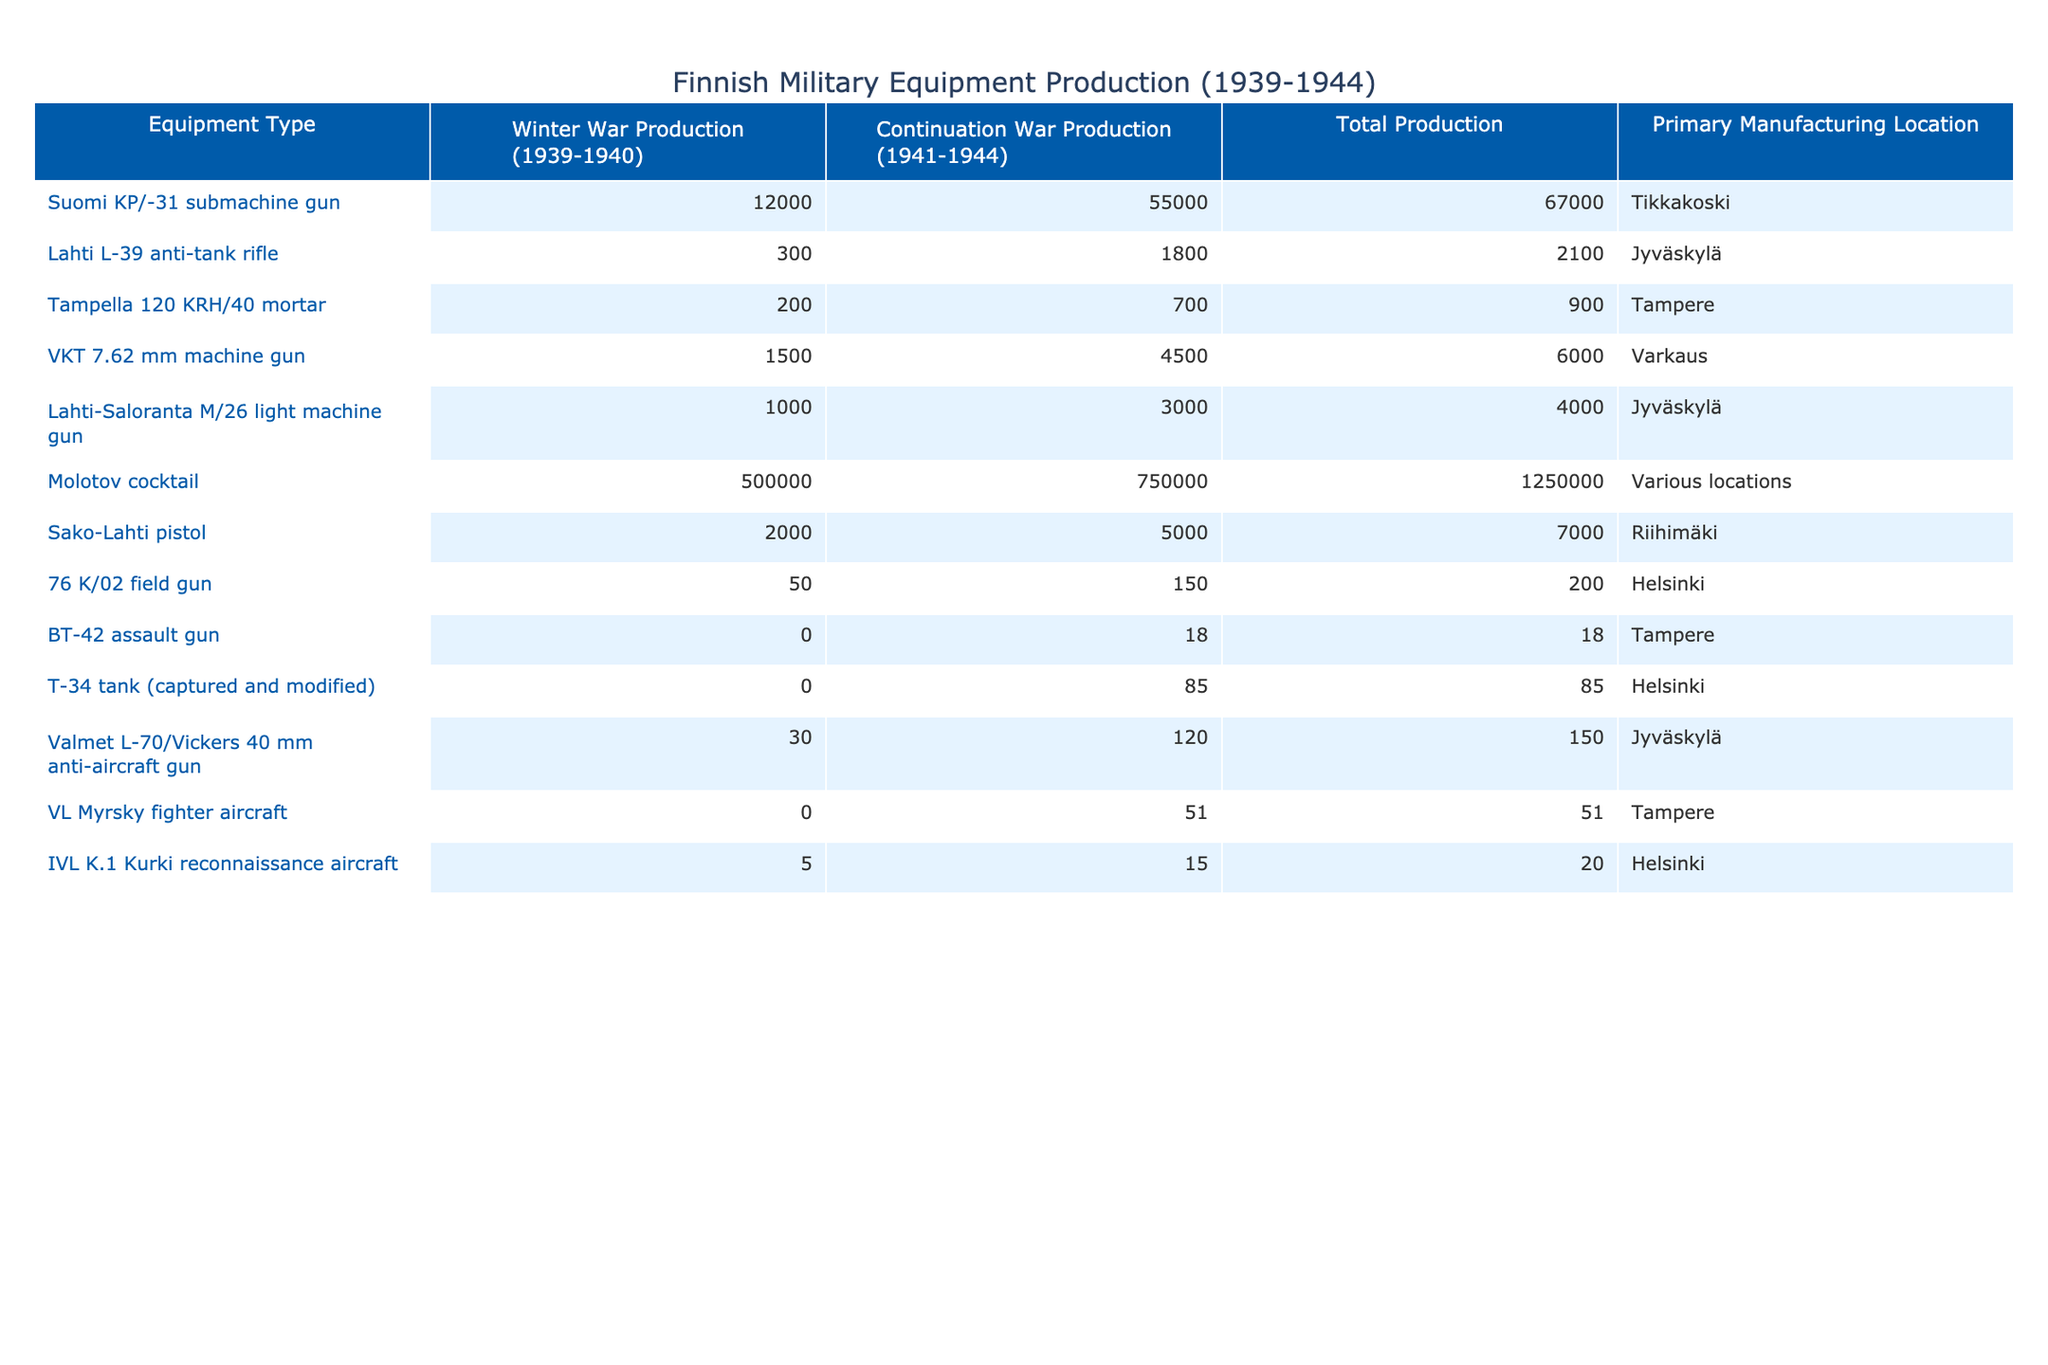What is the total production of the Molotov cocktail during the Winter War and Continuation War? The table shows that the production of the Molotov cocktail was 500,000 during the Winter War and 750,000 during the Continuation War. To find the total, we sum these two figures: 500,000 + 750,000 = 1,250,000.
Answer: 1,250,000 Which equipment was produced at the highest quantity during the Continuation War? The table lists the total production of various equipment during the Continuation War. The highest value is 55,000 for the Suomi KP/-31 submachine gun.
Answer: Suomi KP/-31 submachine gun What is the total production of anti-tank rifles over both wars? According to the table, the Lahti L-39 anti-tank rifle had a Winter War production of 300 and a Continuation War production of 1,800. We add these together: 300 + 1,800 = 2,100.
Answer: 2,100 Did any equipment have zero production during the Winter War? In the table, the BT-42 assault gun and the T-34 tank (captured and modified) both have a Winter War production value of 0. Thus, the statement is true.
Answer: Yes What is the difference in total production between the Suomi KP/-31 submachine gun and the Tampella 120 KRH/40 mortar? The total production for the Suomi KP/-31 is 67,000 and for the Tampella 120 KRH/40 mortar is 900. The difference can be calculated as follows: 67,000 - 900 = 66,100.
Answer: 66,100 Which equipment has the lowest total production, and what was the production location? The data shows that the BT-42 assault gun has the lowest total production, with only 18 units produced. The primary manufacturing location for this equipment is Tampere.
Answer: BT-42 assault gun, Tampere How many weapons were produced in total at the Jyväskylä location? The table indicates that at Jyväskylä, the following equipment was produced: Lahti L-39 anti-tank rifle (2,100), Lahti-Saloranta M/26 light machine gun (4,000), and Valmet L-70/Vickers 40 mm anti-aircraft gun (150). Adding these values gives us: 2,100 + 4,000 + 150 = 6,250.
Answer: 6,250 What fraction of the total production for the Molotov cocktail does the Winter War production represent? The total production for the Molotov cocktail is 1,250,000, with 500,000 produced during the Winter War. The fraction is calculated as 500,000 / 1,250,000 = 0.4 or 40%.
Answer: 40% Is it true that the IVL K.1 Kurki reconnaissance aircraft had more production in the Continuation War than in the Winter War? The IVL K.1 Kurki reconnaissance aircraft had a production of 5 during the Winter War and 15 during the Continuation War. Since 15 is greater than 5, the statement is true.
Answer: Yes What percentage of the total production of the Lahti-Saloranta M/26 light machine gun occurred during the Continuation War? Total production of the Lahti-Saloranta M/26 was 4,000, of which 3,000 units were produced during the Continuation War. The percentage is calculated as (3,000 / 4,000) * 100 = 75%.
Answer: 75% 